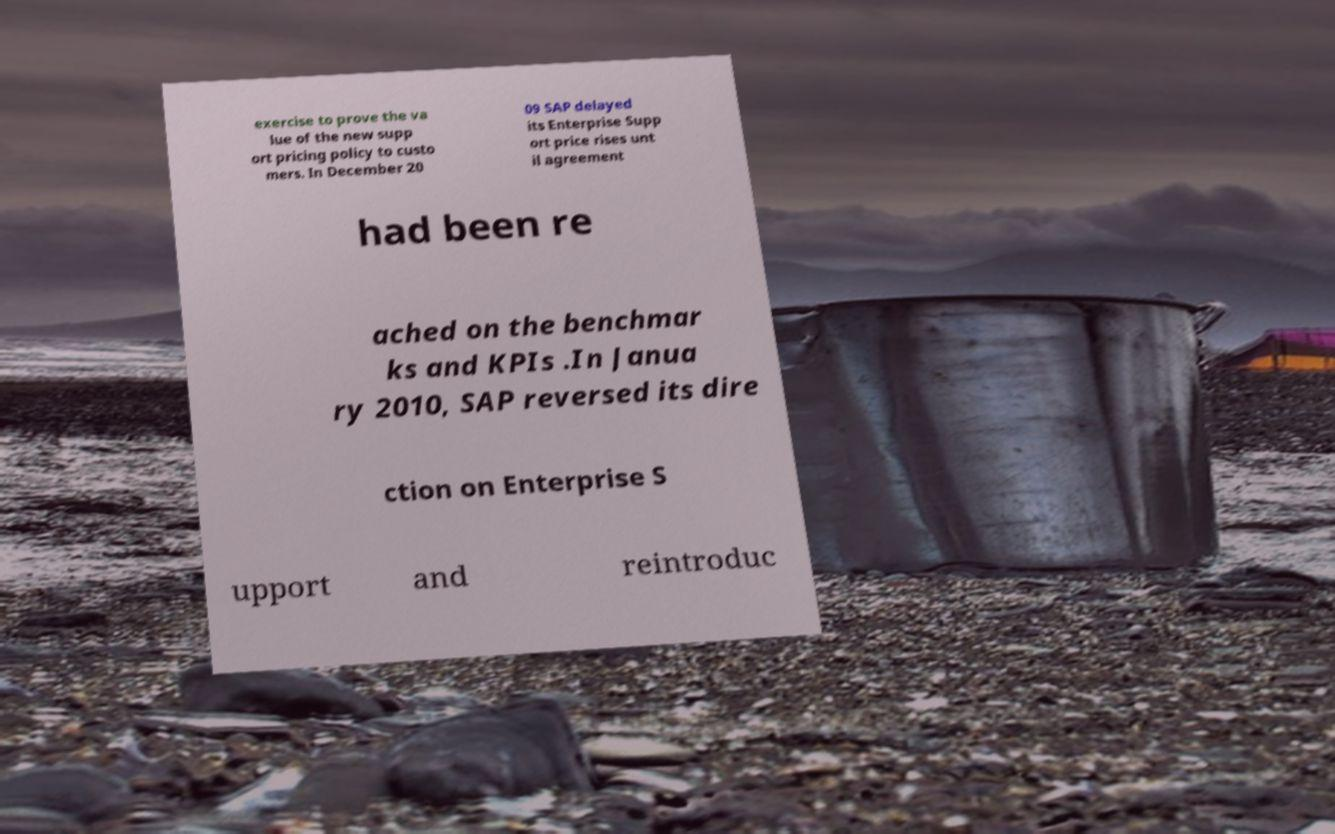Could you assist in decoding the text presented in this image and type it out clearly? exercise to prove the va lue of the new supp ort pricing policy to custo mers. In December 20 09 SAP delayed its Enterprise Supp ort price rises unt il agreement had been re ached on the benchmar ks and KPIs .In Janua ry 2010, SAP reversed its dire ction on Enterprise S upport and reintroduc 